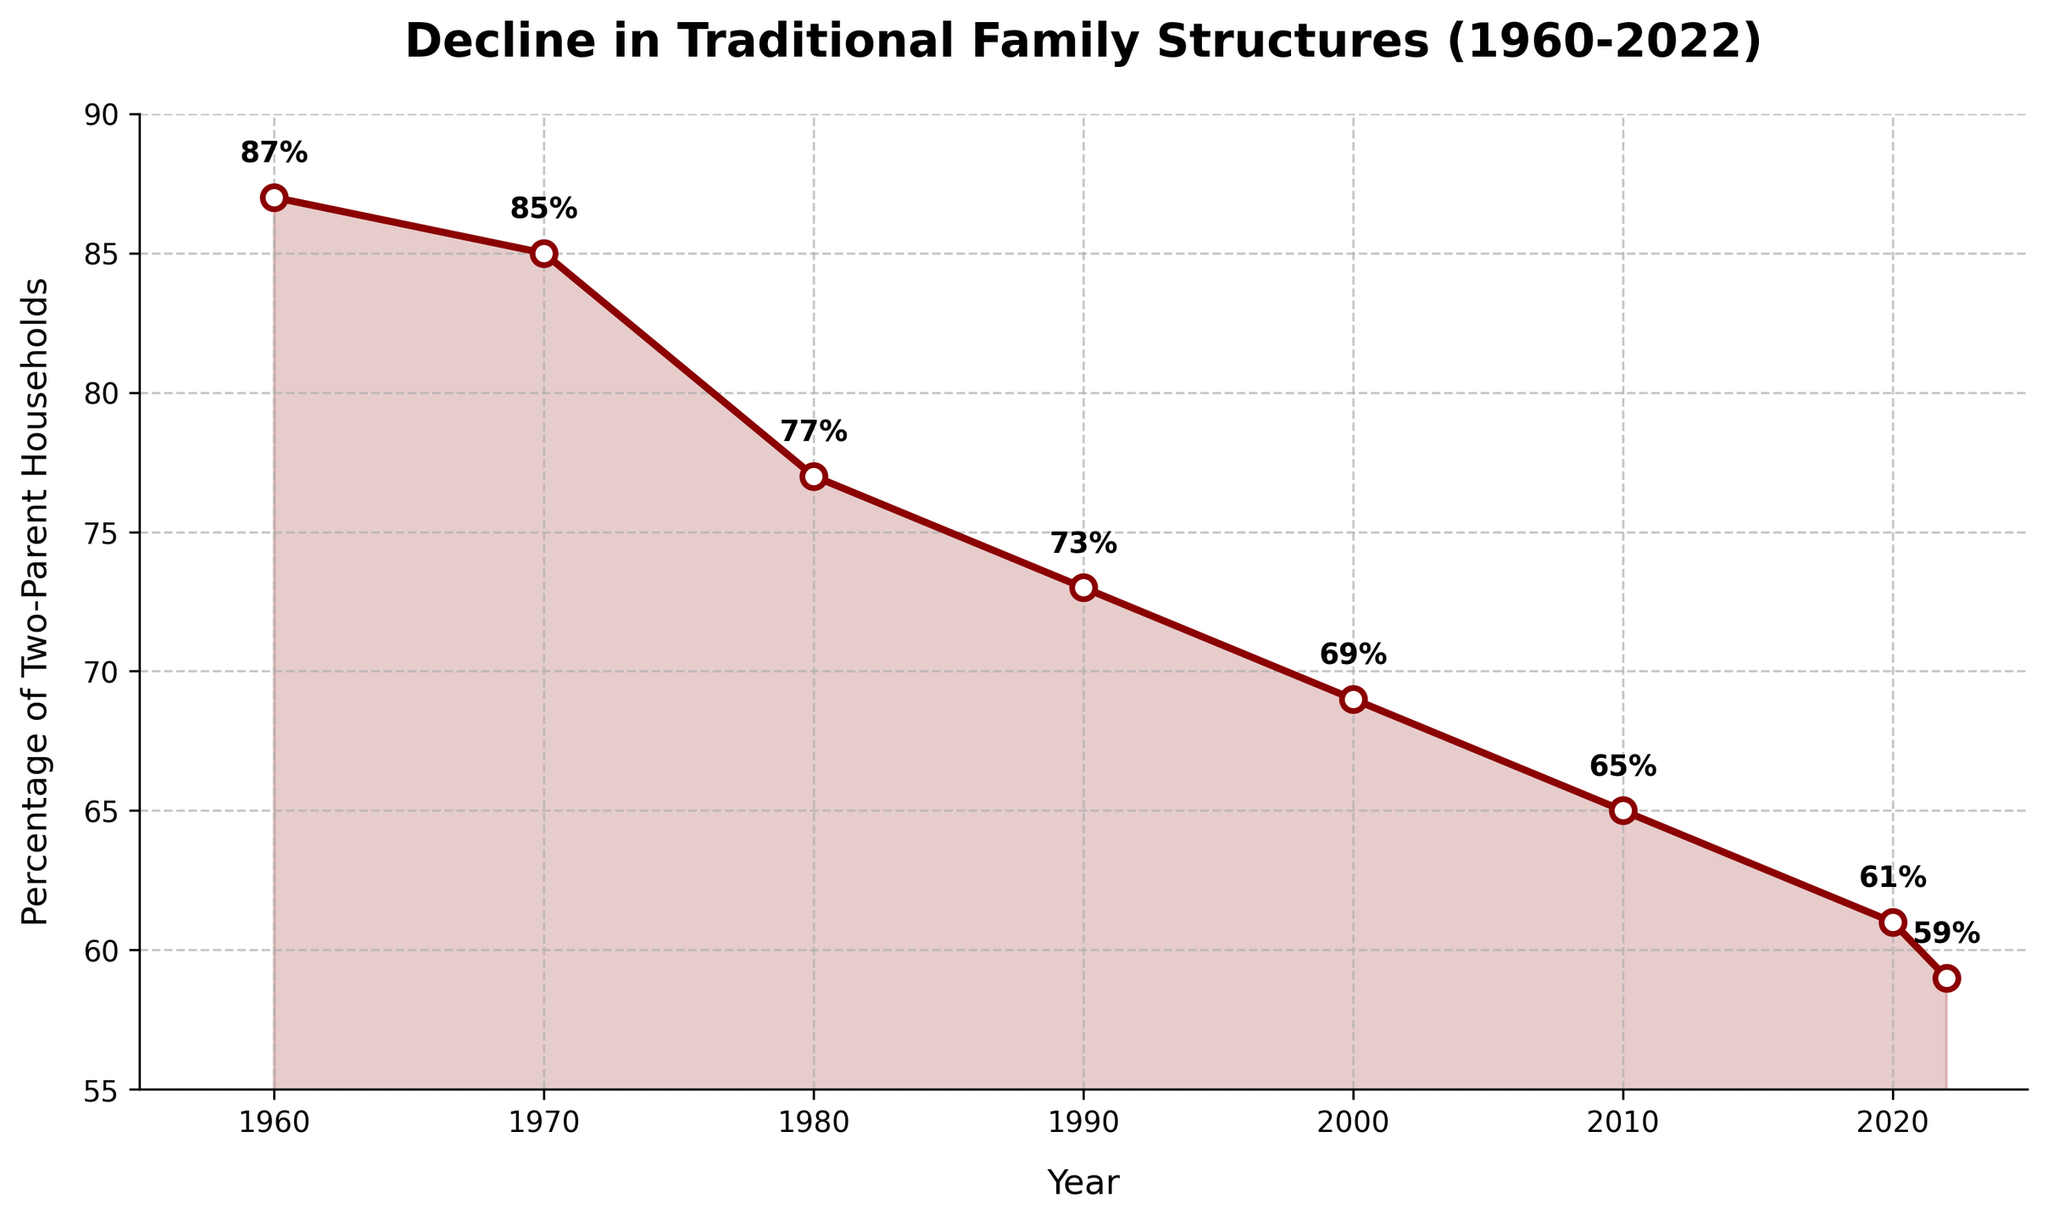What's the percentage decline in two-parent households from 1960 to 2022? The percentage of two-parent households in 1960 was 87% and in 2022 it was 59%. So, the decline is 87 - 59 = 28%
Answer: 28% In which decade did the greatest decline in two-parent households occur? By comparing the percentage declines per decade: 1960-1970: 87-85=2%, 1970-1980: 85-77=8%, 1980-1990: 77-73=4%, 1990-2000: 73-69=4%, 2000-2010: 69-65=4%, 2010-2020: 65-61=4%, 2020-2022: 61-59=2%. The greatest decline occurred from 1970-1980 with an 8% reduction.
Answer: 1970-1980 How has the percentage of two-parent households changed from 1960 to 2000? The percentage of two-parent households in 1960 was 87%, and in 2000 it was 69%. The change is 87 - 69 = 18%.
Answer: 18% By how many percentage points did the number of two-parent households decline between the years 2010 and 2020? In 2010, the percentage was 65%, and in 2020, it was 61%. The decline is 65 - 61 = 4 percentage points.
Answer: 4 What trend is shown in the chart from 1960 to 2022? The chart shows a continuous decline in the percentage of two-parent households from 87% in 1960 to 59% in 2022.
Answer: Continuous decline In what year does the chart show the first significant decline below 80% in two-parent households? The graph shows that in 1980, the percentage of two-parent households dropped below 80%, specifically to 77%.
Answer: 1980 Which year had the highest percentage of two-parent households, and what was the percentage? The year 1960 had the highest percentage of two-parent households, with the percentage being 87%.
Answer: 1960, 87% Which year shows a percentage closest to 60% for two-parent households? The year 2020 shows a percentage closest to 60% for two-parent households, with the percentage being 61%.
Answer: 2020 Between which two consecutive years did the smallest decline in the percentage of two-parent households occur? The smallest decline between consecutive years occurred between 2020 and 2022, with a decline of 61% - 59% = 2%.
Answer: 2020 and 2022 